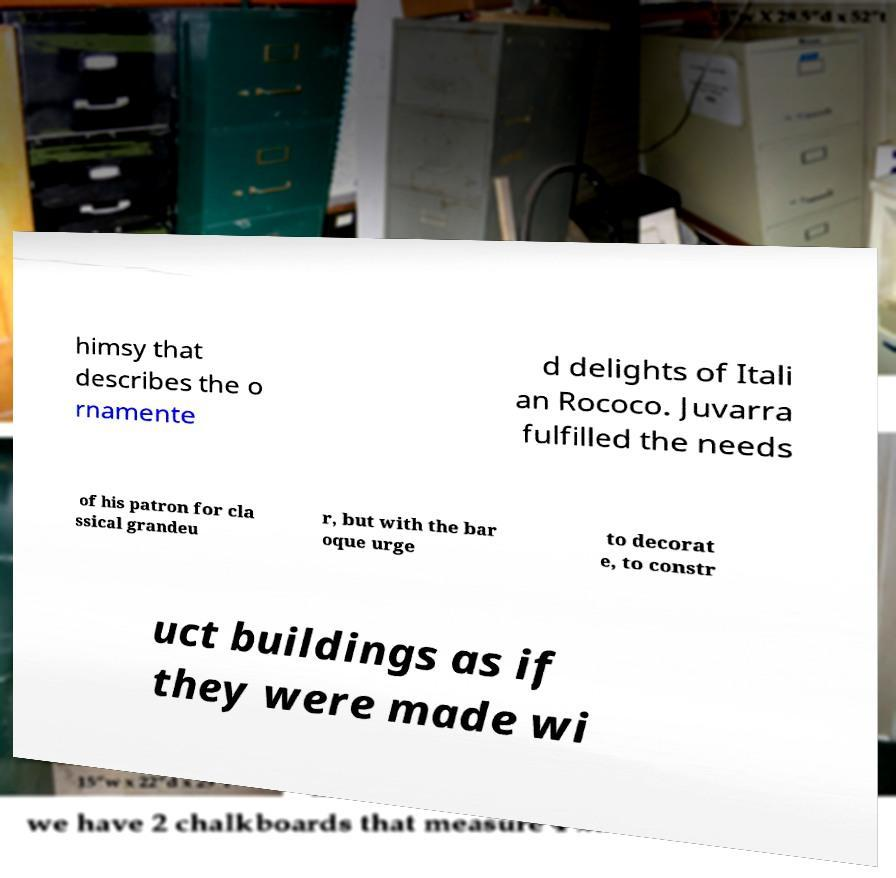Can you read and provide the text displayed in the image?This photo seems to have some interesting text. Can you extract and type it out for me? himsy that describes the o rnamente d delights of Itali an Rococo. Juvarra fulfilled the needs of his patron for cla ssical grandeu r, but with the bar oque urge to decorat e, to constr uct buildings as if they were made wi 